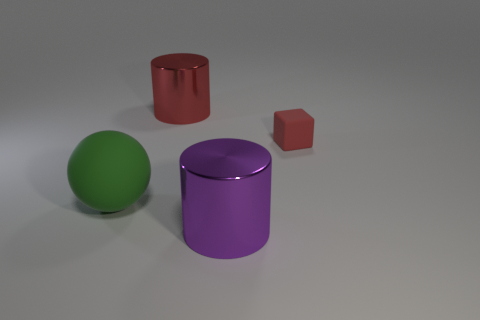Is there any lighting in the scene, and if so, what can you deduce about its source? The scene is illuminated, indicating the presence of a light source, likely above and to the right, given the shadows cast by the objects on the surface. 